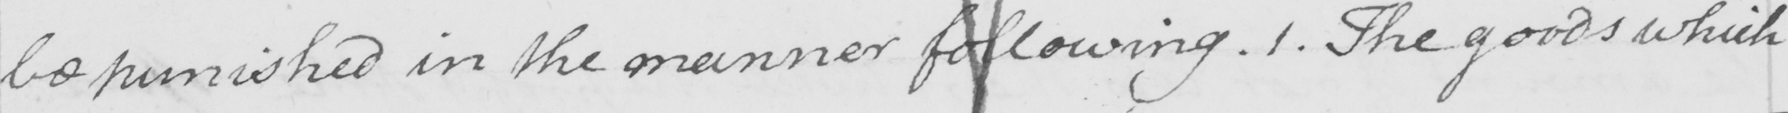Please transcribe the handwritten text in this image. be punished in the manner following . 1 . The goods which 